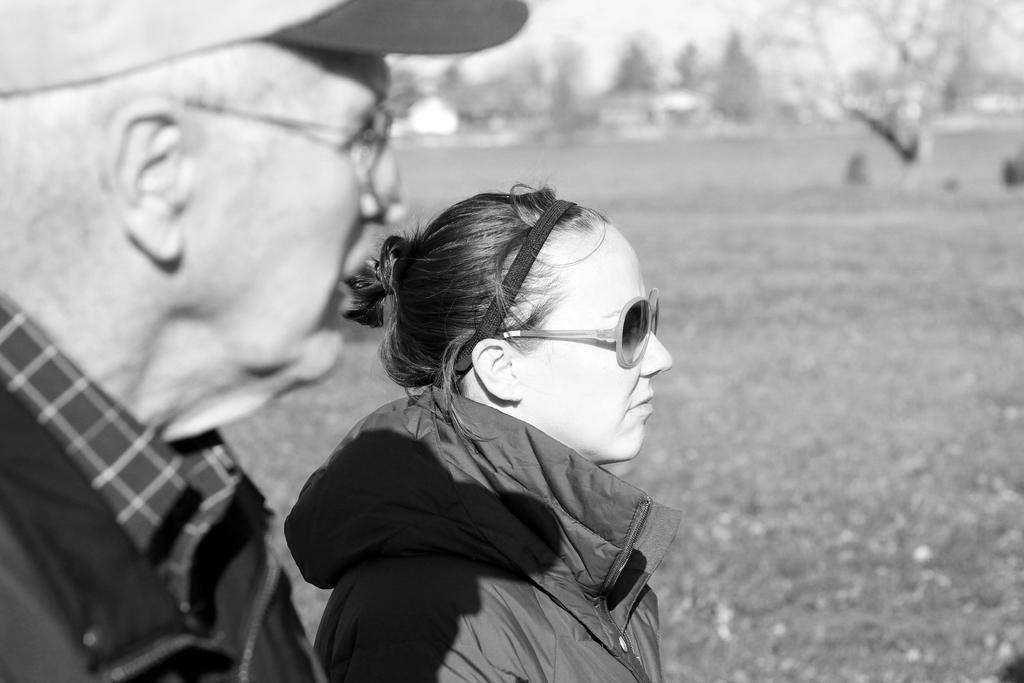What is the color scheme of the image? The image is black and white. What people can be seen in the image? There is a man and a woman in the image. What type of clouds can be seen in the image? There are no clouds present in the image, as it is a black and white image of a man and a woman. 